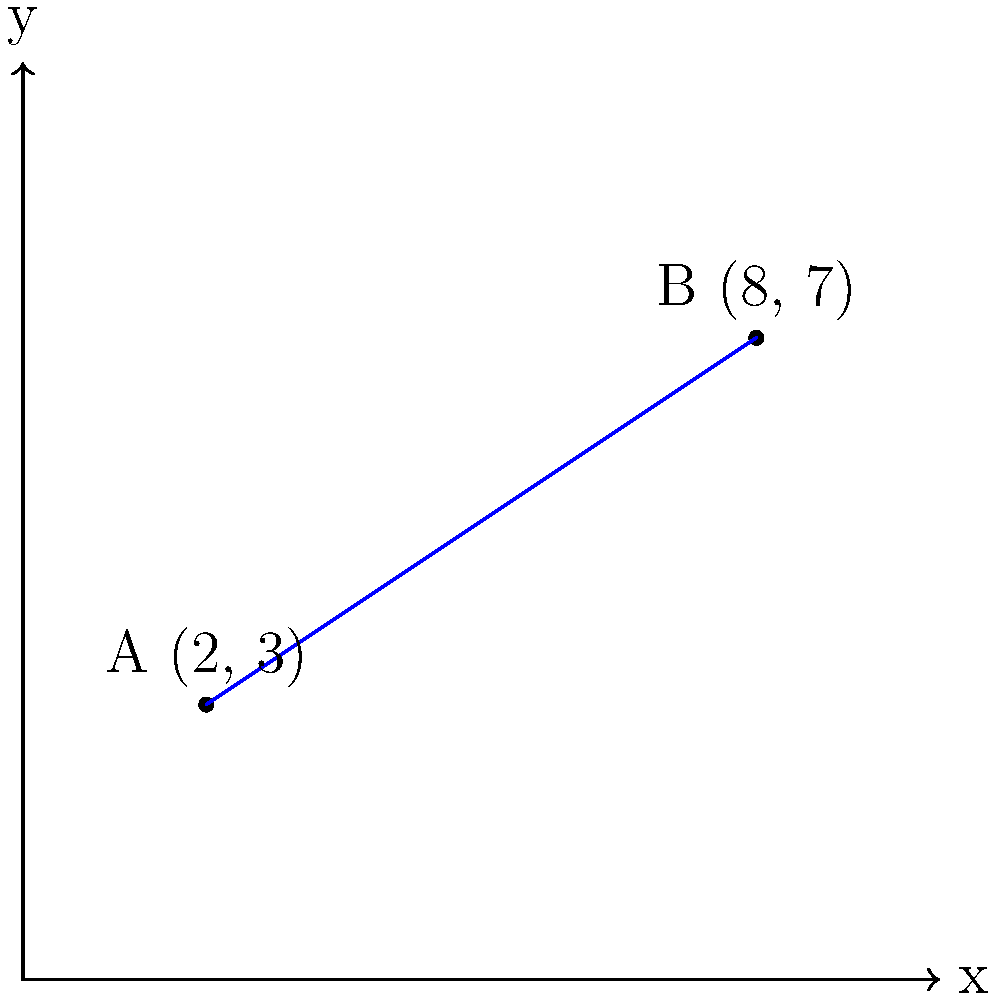As part of a clinical trial for a new cancer treatment, you need to calculate the distance between two treatment centers. Treatment center A is located at coordinates (2, 3), and treatment center B is at coordinates (8, 7). Calculate the distance between these two centers using the distance formula. Round your answer to two decimal places. To solve this problem, we'll use the distance formula between two points:

$d = \sqrt{(x_2 - x_1)^2 + (y_2 - y_1)^2}$

Where $(x_1, y_1)$ represents the coordinates of point A, and $(x_2, y_2)$ represents the coordinates of point B.

Step 1: Identify the coordinates
Point A: $(x_1, y_1) = (2, 3)$
Point B: $(x_2, y_2) = (8, 7)$

Step 2: Substitute the values into the distance formula
$d = \sqrt{(8 - 2)^2 + (7 - 3)^2}$

Step 3: Simplify the expressions inside the parentheses
$d = \sqrt{6^2 + 4^2}$

Step 4: Calculate the squares
$d = \sqrt{36 + 16}$

Step 5: Add the values under the square root
$d = \sqrt{52}$

Step 6: Calculate the square root and round to two decimal places
$d \approx 7.21$

Therefore, the distance between treatment centers A and B is approximately 7.21 units.
Answer: 7.21 units 